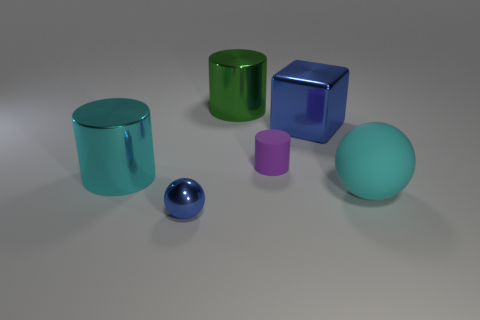Are there an equal number of large matte objects that are left of the large block and large blue matte balls?
Offer a very short reply. Yes. What number of metallic cubes are the same size as the cyan cylinder?
Provide a short and direct response. 1. What shape is the object that is the same color as the block?
Provide a short and direct response. Sphere. Are there any yellow rubber things?
Your response must be concise. No. There is a large shiny thing behind the big blue metal cube; is it the same shape as the cyan object to the left of the tiny rubber cylinder?
Keep it short and to the point. Yes. How many small things are cyan rubber balls or cyan metallic cylinders?
Ensure brevity in your answer.  0. What shape is the blue object that is the same material as the tiny sphere?
Give a very brief answer. Cube. Is the shape of the green object the same as the large cyan metal thing?
Make the answer very short. Yes. The tiny shiny object is what color?
Keep it short and to the point. Blue. How many objects are big cyan metal cylinders or matte balls?
Give a very brief answer. 2. 